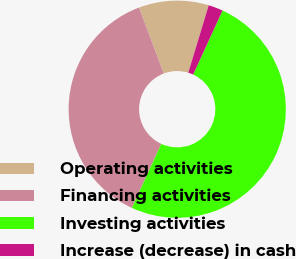Convert chart to OTSL. <chart><loc_0><loc_0><loc_500><loc_500><pie_chart><fcel>Operating activities<fcel>Financing activities<fcel>Investing activities<fcel>Increase (decrease) in cash<nl><fcel>10.41%<fcel>37.42%<fcel>50.0%<fcel>2.17%<nl></chart> 